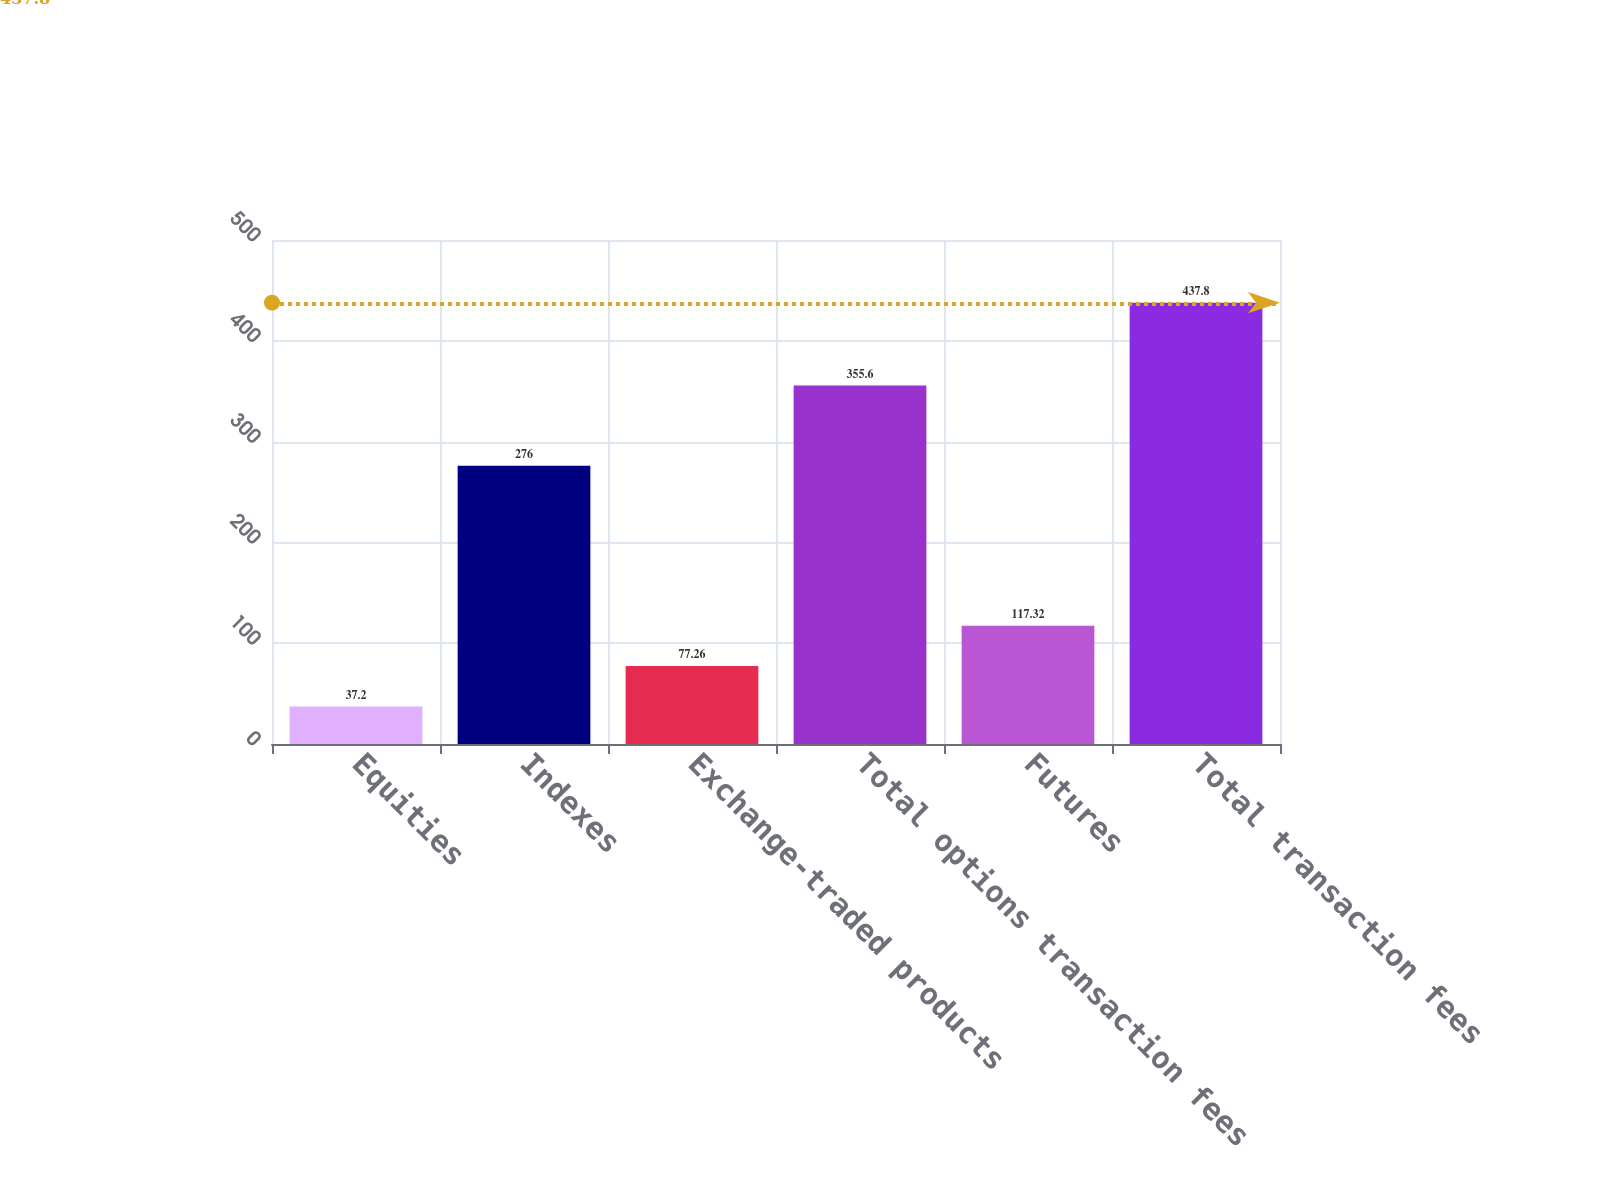Convert chart. <chart><loc_0><loc_0><loc_500><loc_500><bar_chart><fcel>Equities<fcel>Indexes<fcel>Exchange-traded products<fcel>Total options transaction fees<fcel>Futures<fcel>Total transaction fees<nl><fcel>37.2<fcel>276<fcel>77.26<fcel>355.6<fcel>117.32<fcel>437.8<nl></chart> 